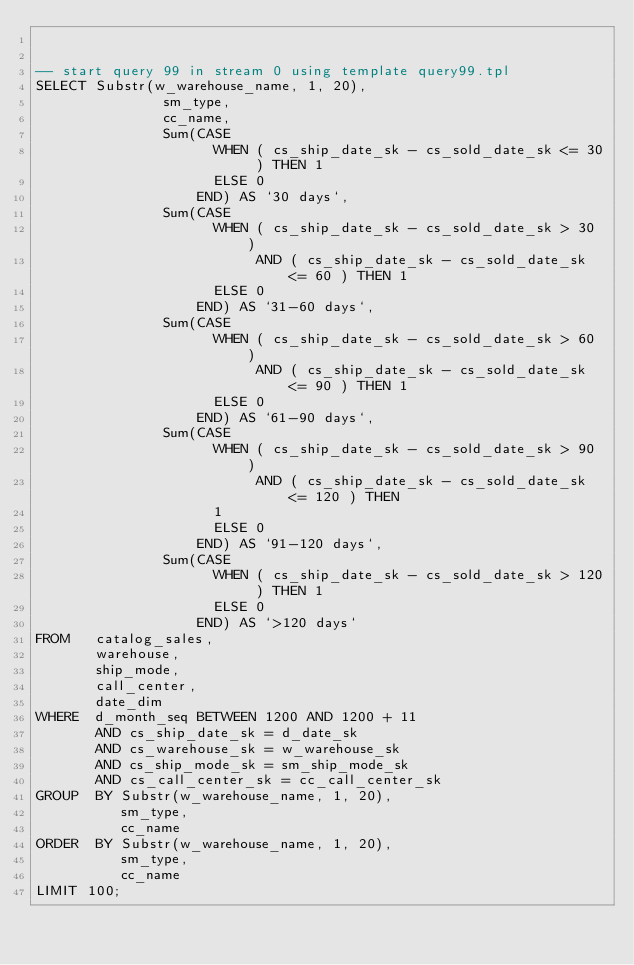<code> <loc_0><loc_0><loc_500><loc_500><_SQL_>

-- start query 99 in stream 0 using template query99.tpl 
SELECT Substr(w_warehouse_name, 1, 20), 
               sm_type, 
               cc_name, 
               Sum(CASE 
                     WHEN ( cs_ship_date_sk - cs_sold_date_sk <= 30 ) THEN 1 
                     ELSE 0 
                   END) AS `30 days`, 
               Sum(CASE 
                     WHEN ( cs_ship_date_sk - cs_sold_date_sk > 30 ) 
                          AND ( cs_ship_date_sk - cs_sold_date_sk <= 60 ) THEN 1 
                     ELSE 0 
                   END) AS `31-60 days`, 
               Sum(CASE 
                     WHEN ( cs_ship_date_sk - cs_sold_date_sk > 60 ) 
                          AND ( cs_ship_date_sk - cs_sold_date_sk <= 90 ) THEN 1 
                     ELSE 0 
                   END) AS `61-90 days`, 
               Sum(CASE 
                     WHEN ( cs_ship_date_sk - cs_sold_date_sk > 90 ) 
                          AND ( cs_ship_date_sk - cs_sold_date_sk <= 120 ) THEN 
                     1 
                     ELSE 0 
                   END) AS `91-120 days`, 
               Sum(CASE 
                     WHEN ( cs_ship_date_sk - cs_sold_date_sk > 120 ) THEN 1 
                     ELSE 0 
                   END) AS `>120 days` 
FROM   catalog_sales, 
       warehouse, 
       ship_mode, 
       call_center, 
       date_dim 
WHERE  d_month_seq BETWEEN 1200 AND 1200 + 11 
       AND cs_ship_date_sk = d_date_sk 
       AND cs_warehouse_sk = w_warehouse_sk 
       AND cs_ship_mode_sk = sm_ship_mode_sk 
       AND cs_call_center_sk = cc_call_center_sk 
GROUP  BY Substr(w_warehouse_name, 1, 20), 
          sm_type, 
          cc_name 
ORDER  BY Substr(w_warehouse_name, 1, 20), 
          sm_type, 
          cc_name
LIMIT 100; 
</code> 